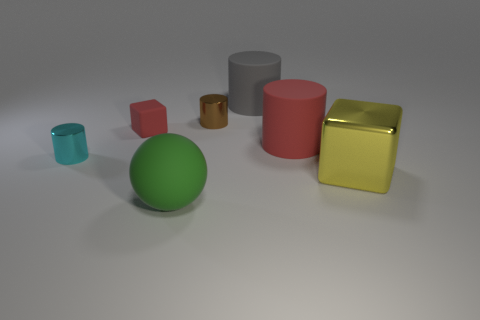Are there an equal number of cyan cylinders that are to the right of the tiny matte block and large shiny blocks that are behind the large gray object?
Provide a short and direct response. Yes. Is the number of tiny cubes greater than the number of big purple shiny blocks?
Offer a terse response. Yes. How many metal objects are either big purple cylinders or spheres?
Offer a terse response. 0. How many large matte objects have the same color as the small matte thing?
Your answer should be very brief. 1. There is a tiny cylinder that is behind the large rubber cylinder that is in front of the rubber cylinder behind the red cylinder; what is its material?
Provide a succinct answer. Metal. What is the color of the rubber thing behind the tiny shiny object behind the cyan metallic cylinder?
Make the answer very short. Gray. How many large objects are either yellow blocks or green spheres?
Give a very brief answer. 2. What number of gray things are made of the same material as the tiny brown cylinder?
Your answer should be compact. 0. There is a object that is in front of the large yellow thing; how big is it?
Ensure brevity in your answer.  Large. There is a metallic thing in front of the metallic cylinder that is on the left side of the big green thing; what shape is it?
Provide a succinct answer. Cube. 